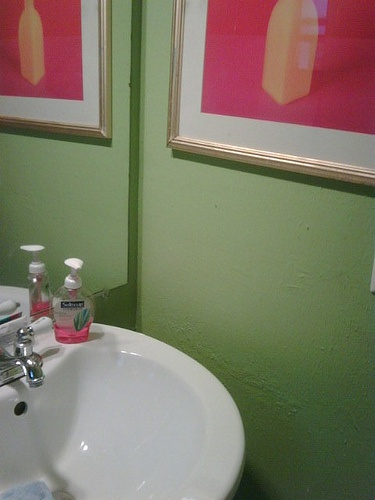Describe the objects in this image and their specific colors. I can see sink in brown, darkgray, and gray tones, vase in brown, salmon, and tan tones, bottle in brown, gray, darkgray, and darkgreen tones, and bottle in brown, gray, and darkgray tones in this image. 